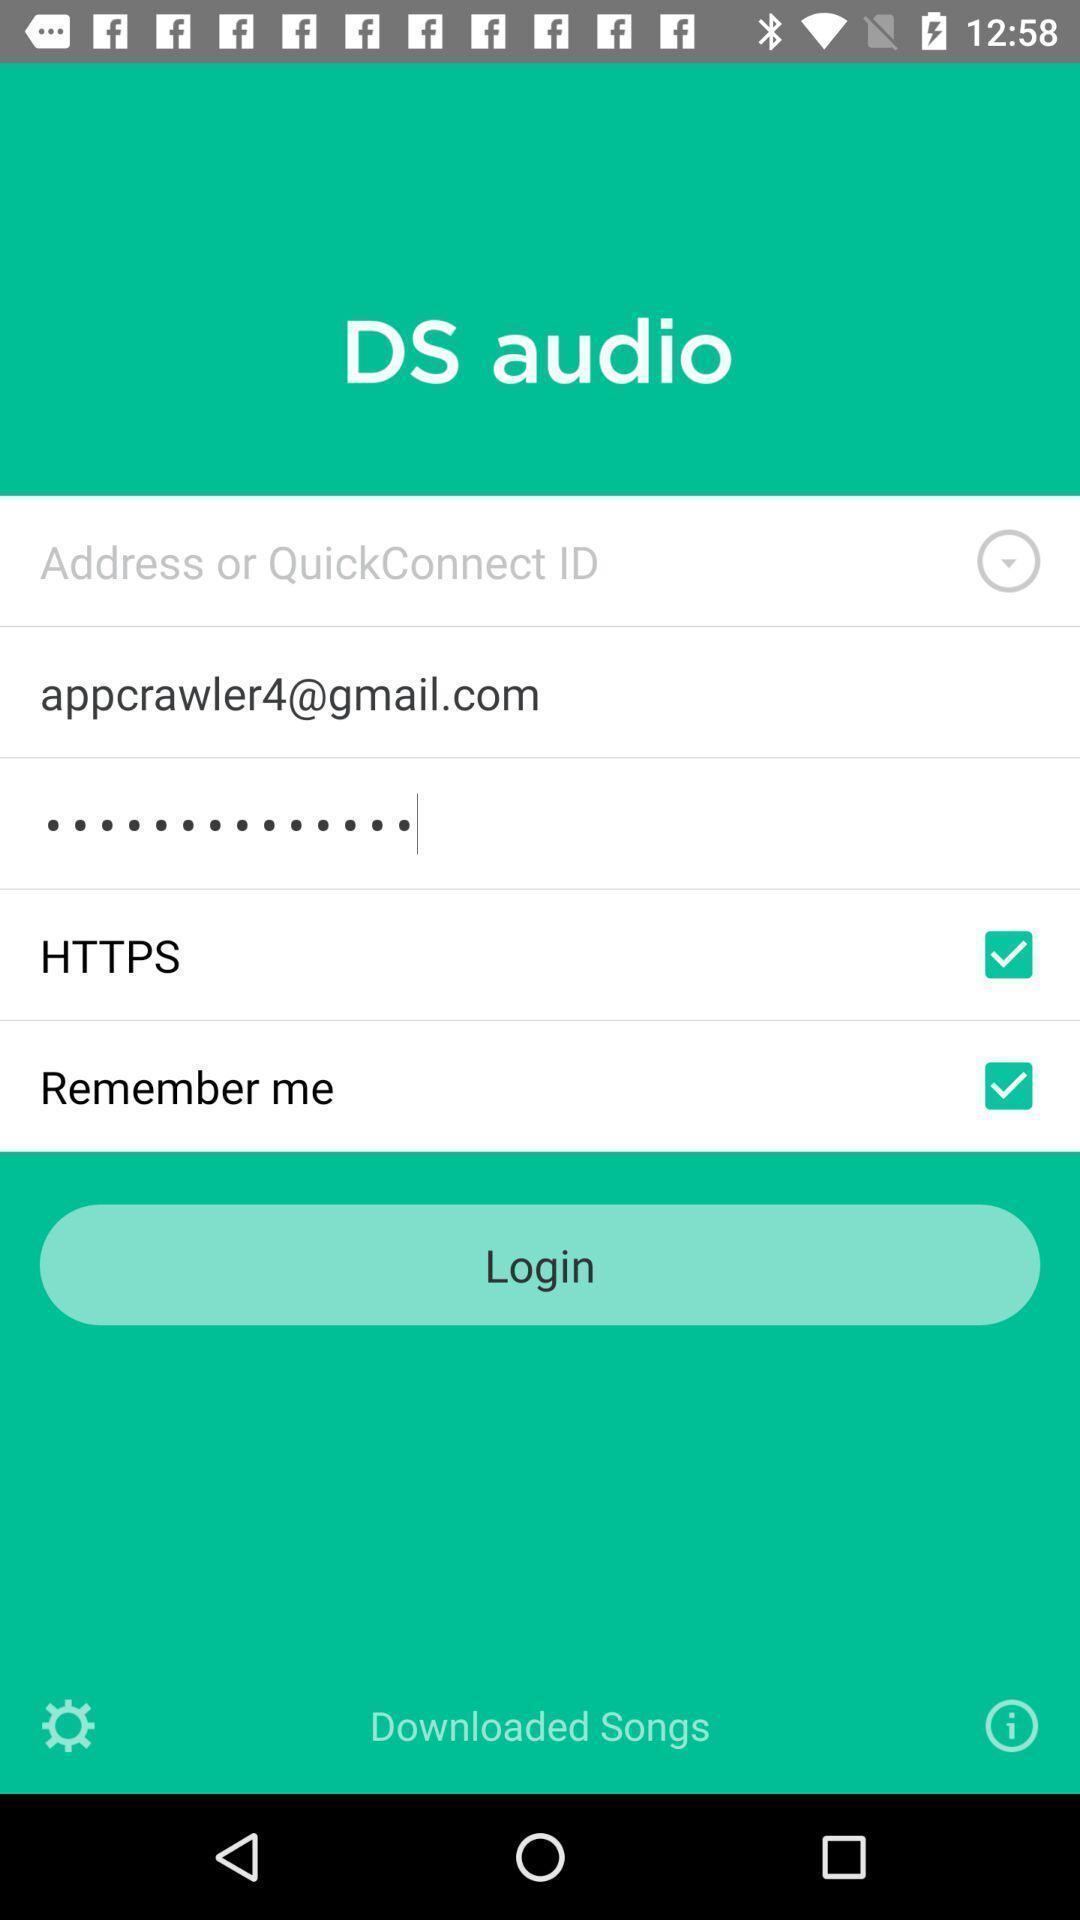Tell me about the visual elements in this screen capture. Page displaying to login account. 